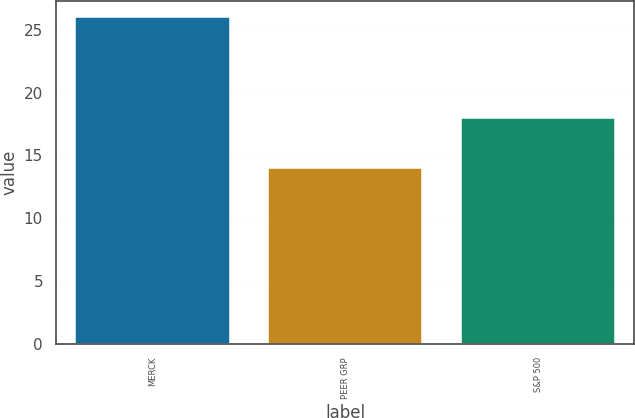Convert chart. <chart><loc_0><loc_0><loc_500><loc_500><bar_chart><fcel>MERCK<fcel>PEER GRP<fcel>S&P 500<nl><fcel>26<fcel>14<fcel>18<nl></chart> 